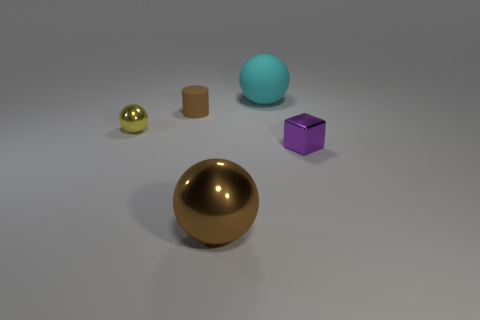Subtract all metal spheres. How many spheres are left? 1 Add 2 small yellow rubber balls. How many objects exist? 7 Subtract all brown balls. How many balls are left? 2 Subtract 0 purple cylinders. How many objects are left? 5 Subtract all blocks. How many objects are left? 4 Subtract 1 cubes. How many cubes are left? 0 Subtract all cyan cylinders. Subtract all brown spheres. How many cylinders are left? 1 Subtract all yellow balls. How many yellow blocks are left? 0 Subtract all red cylinders. Subtract all tiny blocks. How many objects are left? 4 Add 5 purple things. How many purple things are left? 6 